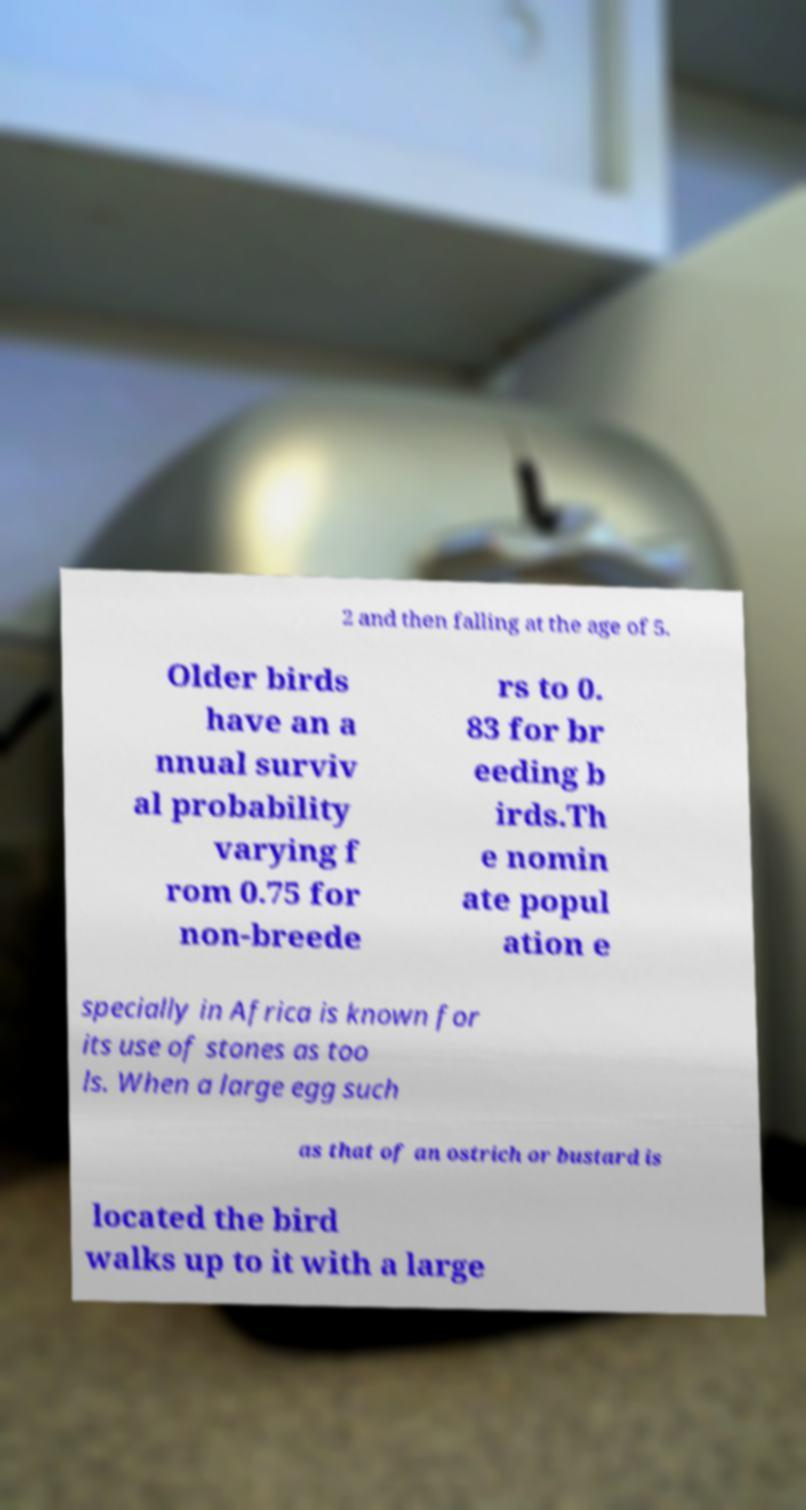Can you accurately transcribe the text from the provided image for me? 2 and then falling at the age of 5. Older birds have an a nnual surviv al probability varying f rom 0.75 for non-breede rs to 0. 83 for br eeding b irds.Th e nomin ate popul ation e specially in Africa is known for its use of stones as too ls. When a large egg such as that of an ostrich or bustard is located the bird walks up to it with a large 